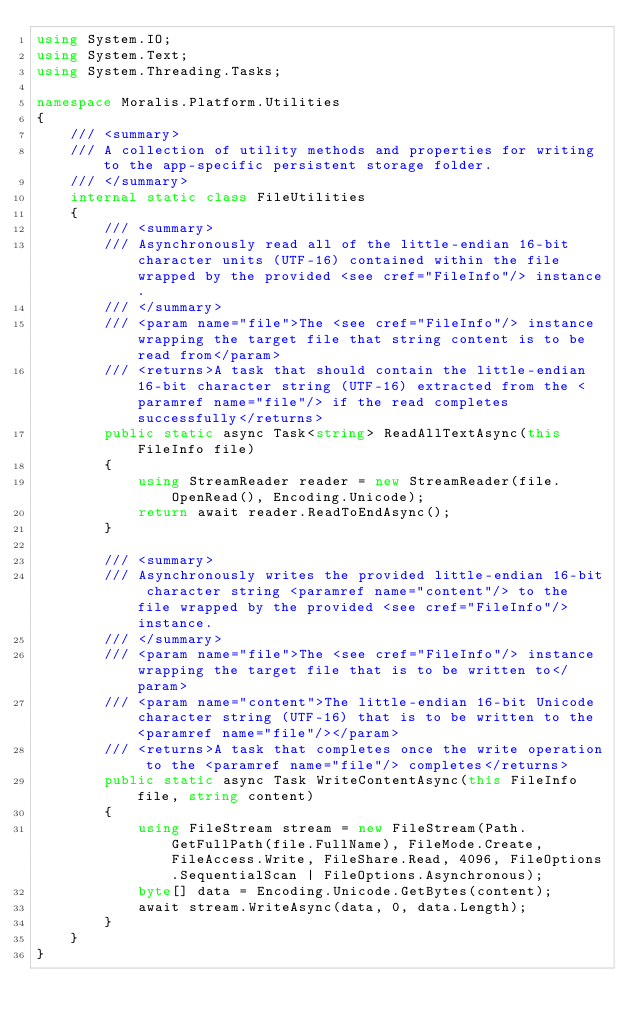<code> <loc_0><loc_0><loc_500><loc_500><_C#_>using System.IO;
using System.Text;
using System.Threading.Tasks;

namespace Moralis.Platform.Utilities
{
    /// <summary>
    /// A collection of utility methods and properties for writing to the app-specific persistent storage folder.
    /// </summary>
    internal static class FileUtilities
    {
        /// <summary>
        /// Asynchronously read all of the little-endian 16-bit character units (UTF-16) contained within the file wrapped by the provided <see cref="FileInfo"/> instance.
        /// </summary>
        /// <param name="file">The <see cref="FileInfo"/> instance wrapping the target file that string content is to be read from</param>
        /// <returns>A task that should contain the little-endian 16-bit character string (UTF-16) extracted from the <paramref name="file"/> if the read completes successfully</returns>
        public static async Task<string> ReadAllTextAsync(this FileInfo file)
        {
            using StreamReader reader = new StreamReader(file.OpenRead(), Encoding.Unicode);
            return await reader.ReadToEndAsync();
        }

        /// <summary>
        /// Asynchronously writes the provided little-endian 16-bit character string <paramref name="content"/> to the file wrapped by the provided <see cref="FileInfo"/> instance.
        /// </summary>
        /// <param name="file">The <see cref="FileInfo"/> instance wrapping the target file that is to be written to</param>
        /// <param name="content">The little-endian 16-bit Unicode character string (UTF-16) that is to be written to the <paramref name="file"/></param>
        /// <returns>A task that completes once the write operation to the <paramref name="file"/> completes</returns>
        public static async Task WriteContentAsync(this FileInfo file, string content)
        {
            using FileStream stream = new FileStream(Path.GetFullPath(file.FullName), FileMode.Create, FileAccess.Write, FileShare.Read, 4096, FileOptions.SequentialScan | FileOptions.Asynchronous);
            byte[] data = Encoding.Unicode.GetBytes(content);
            await stream.WriteAsync(data, 0, data.Length);
        }
    }
}
</code> 